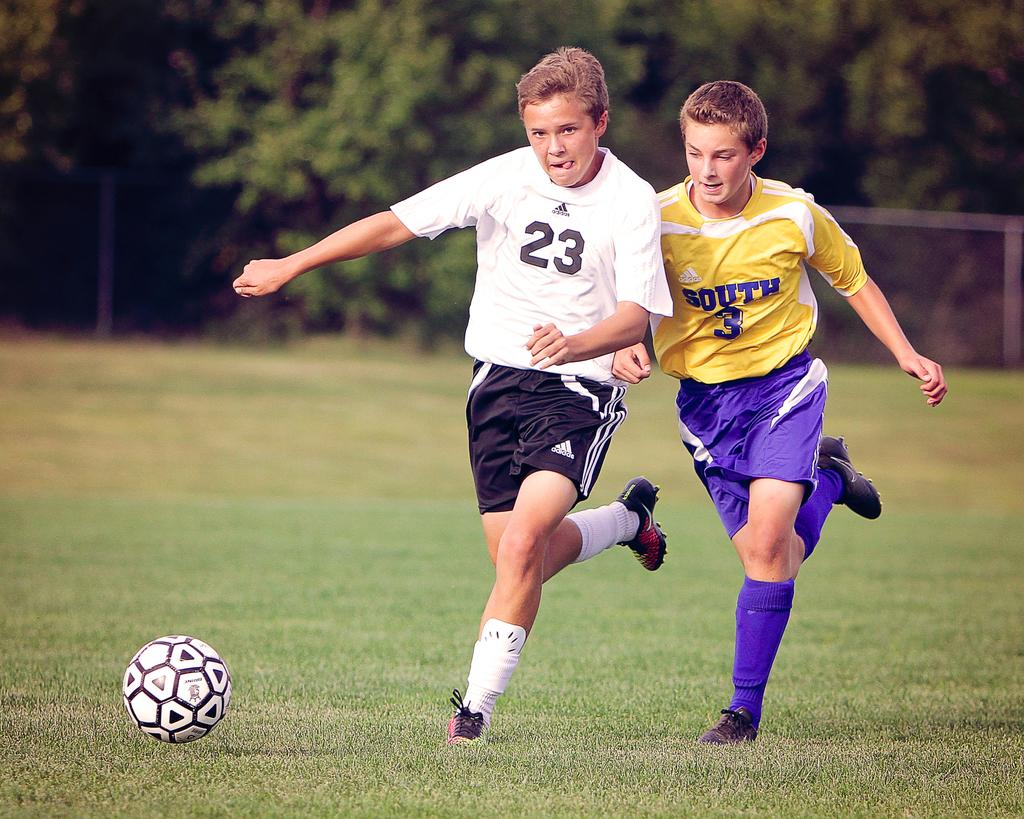<image>
Share a concise interpretation of the image provided. number 3 soccer player is trying to get to the ball 